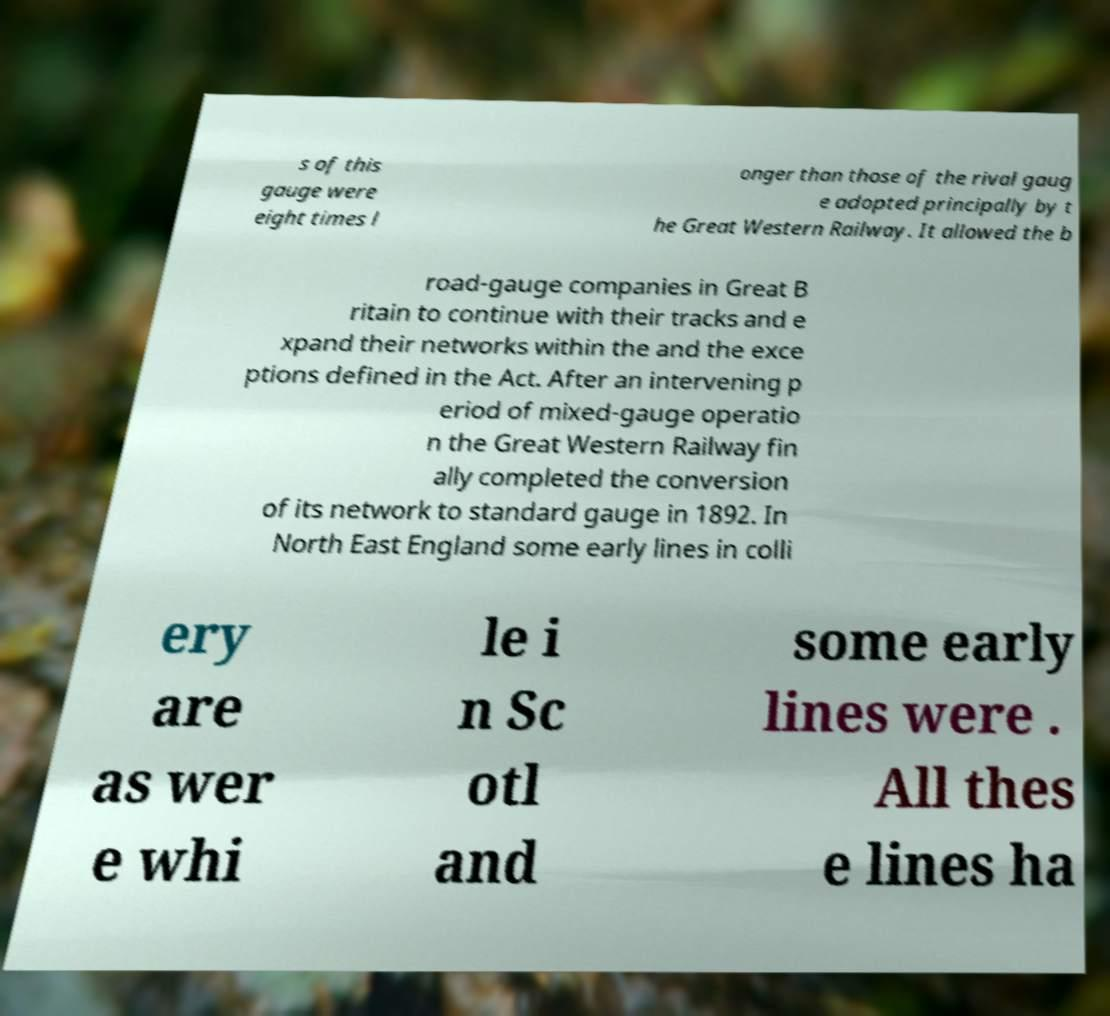Please identify and transcribe the text found in this image. s of this gauge were eight times l onger than those of the rival gaug e adopted principally by t he Great Western Railway. It allowed the b road-gauge companies in Great B ritain to continue with their tracks and e xpand their networks within the and the exce ptions defined in the Act. After an intervening p eriod of mixed-gauge operatio n the Great Western Railway fin ally completed the conversion of its network to standard gauge in 1892. In North East England some early lines in colli ery are as wer e whi le i n Sc otl and some early lines were . All thes e lines ha 